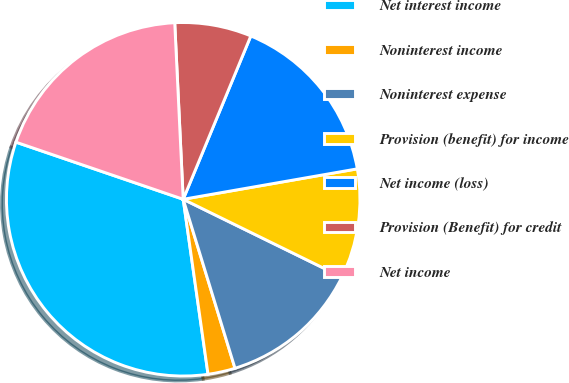Convert chart to OTSL. <chart><loc_0><loc_0><loc_500><loc_500><pie_chart><fcel>Net interest income<fcel>Noninterest income<fcel>Noninterest expense<fcel>Provision (benefit) for income<fcel>Net income (loss)<fcel>Provision (Benefit) for credit<fcel>Net income<nl><fcel>32.48%<fcel>2.49%<fcel>13.01%<fcel>10.01%<fcel>16.0%<fcel>7.01%<fcel>19.0%<nl></chart> 